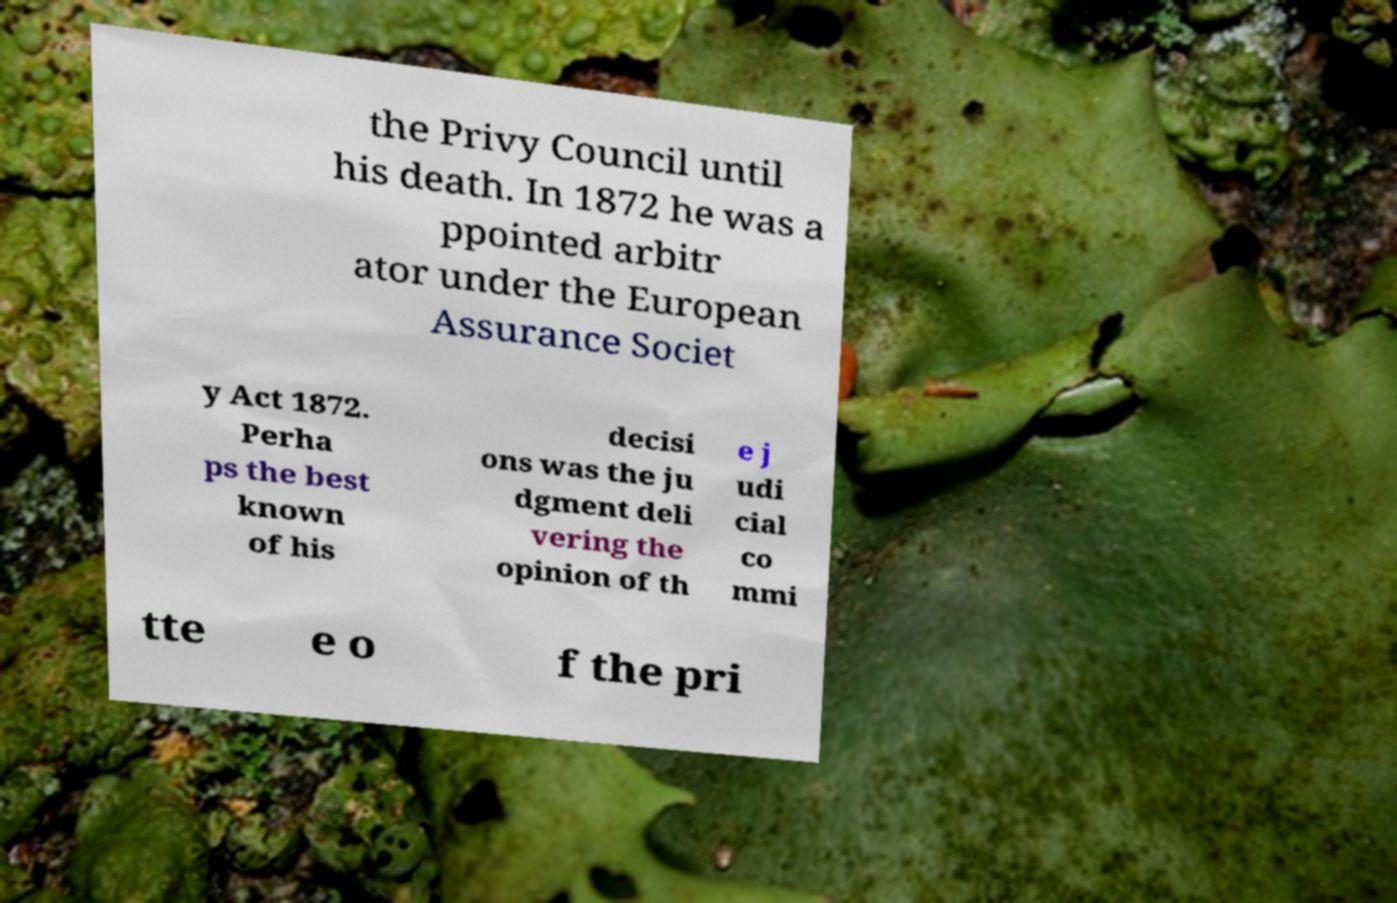There's text embedded in this image that I need extracted. Can you transcribe it verbatim? the Privy Council until his death. In 1872 he was a ppointed arbitr ator under the European Assurance Societ y Act 1872. Perha ps the best known of his decisi ons was the ju dgment deli vering the opinion of th e j udi cial co mmi tte e o f the pri 